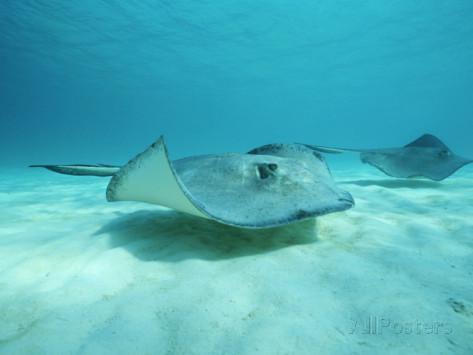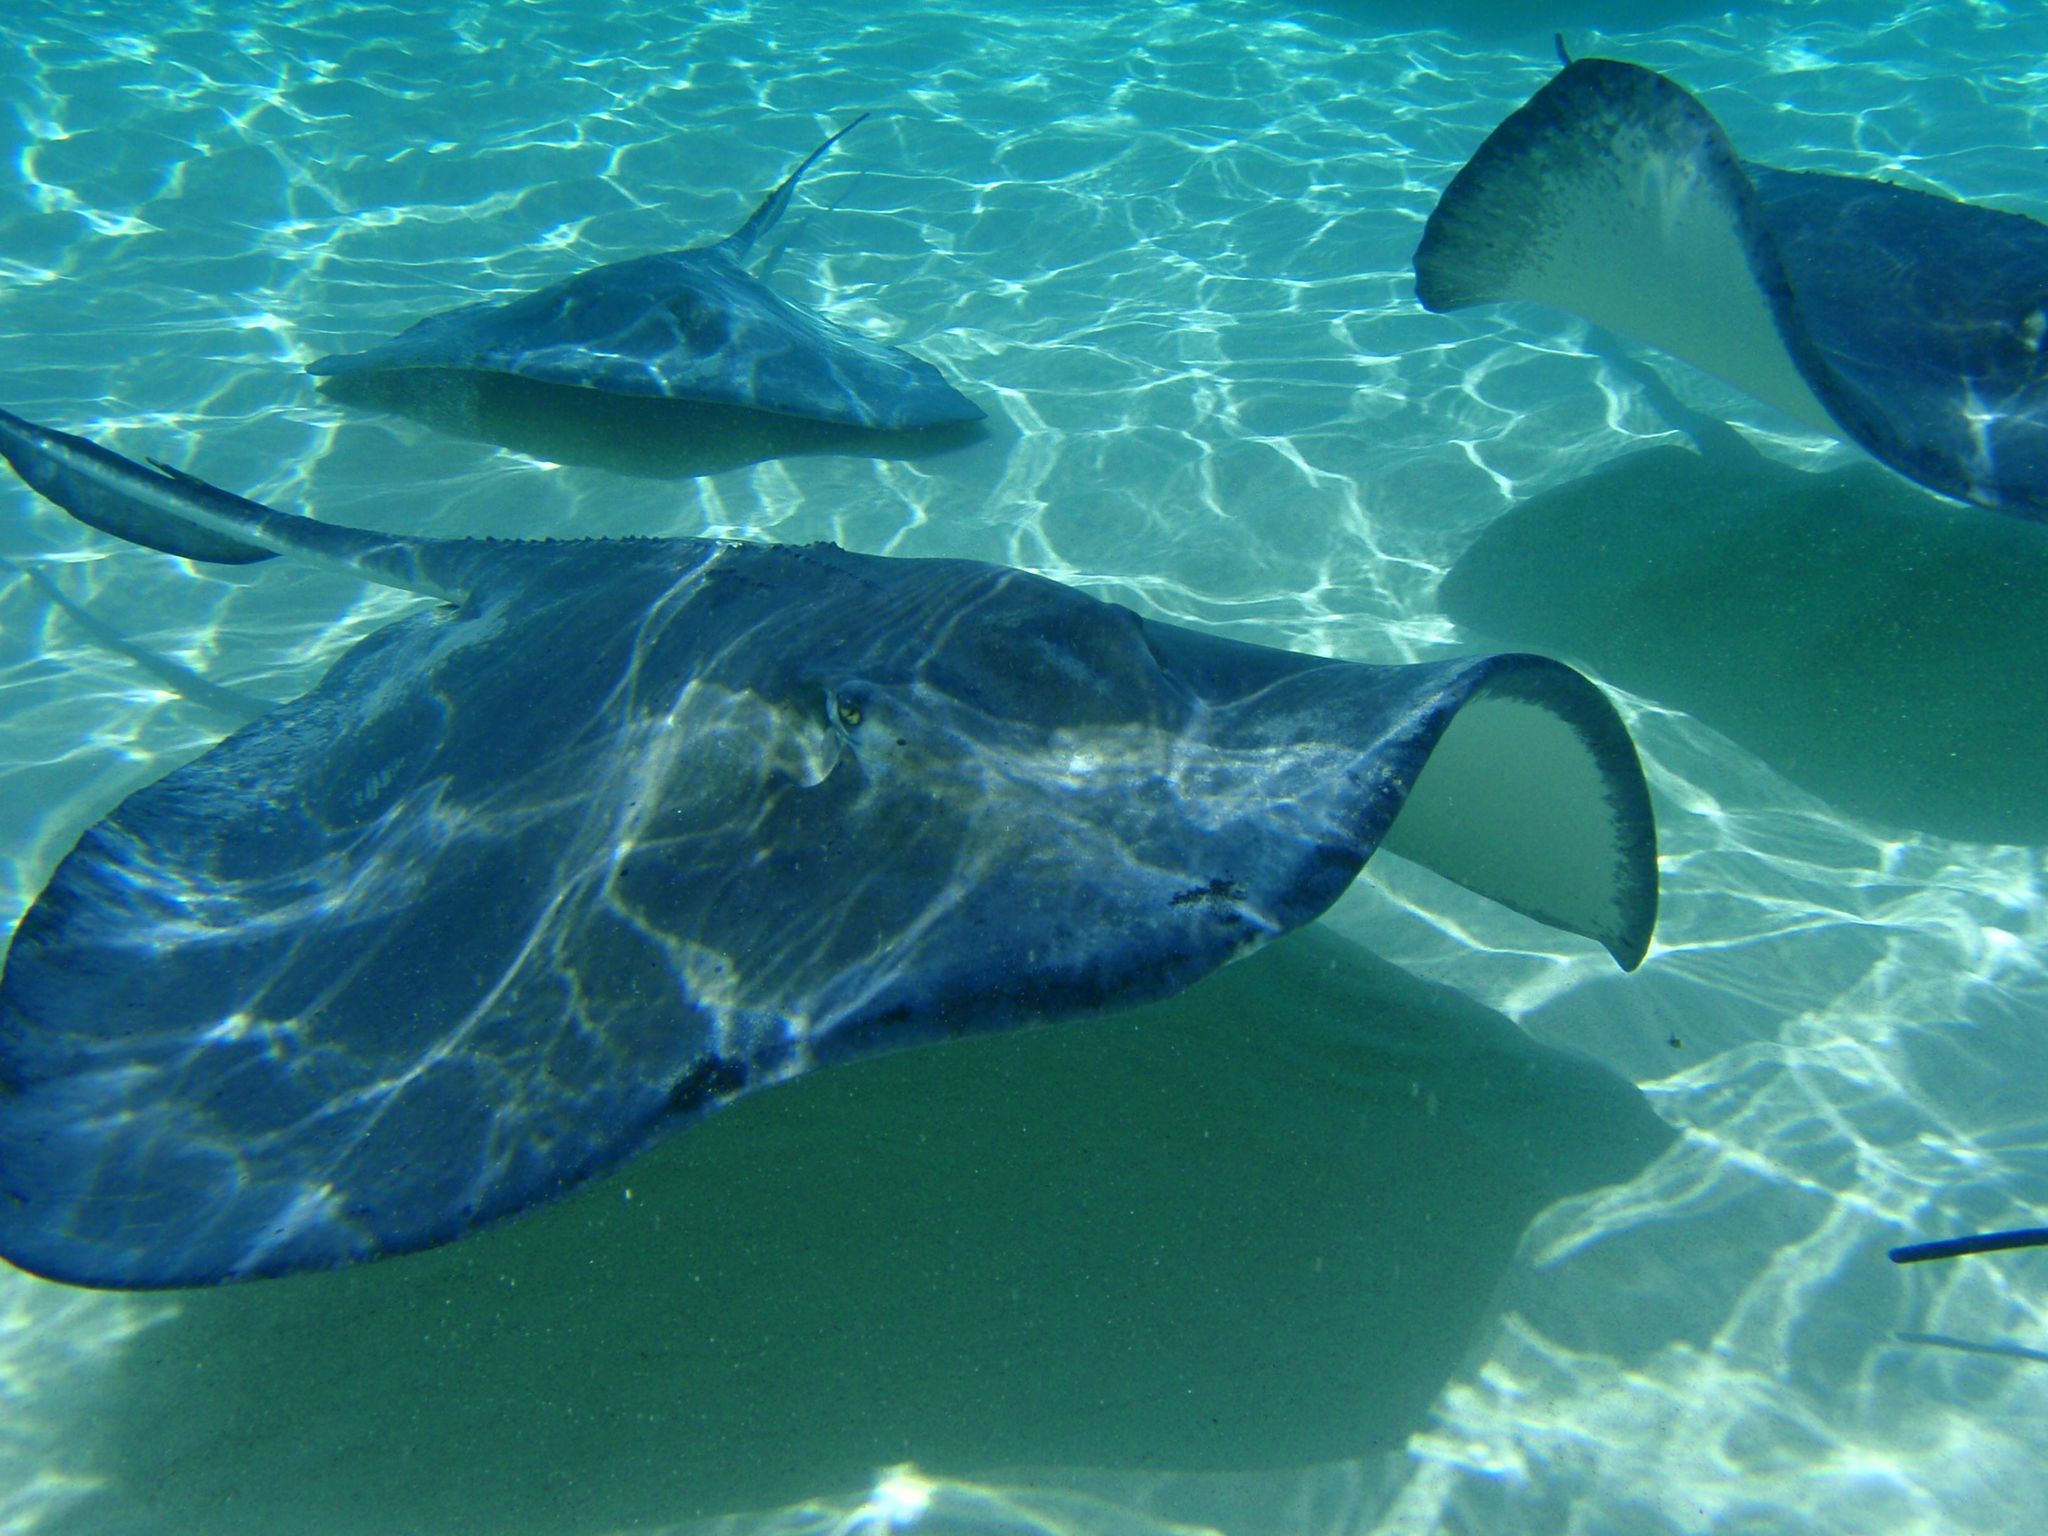The first image is the image on the left, the second image is the image on the right. Assess this claim about the two images: "The left image shows two rays moving toward the right.". Correct or not? Answer yes or no. Yes. 